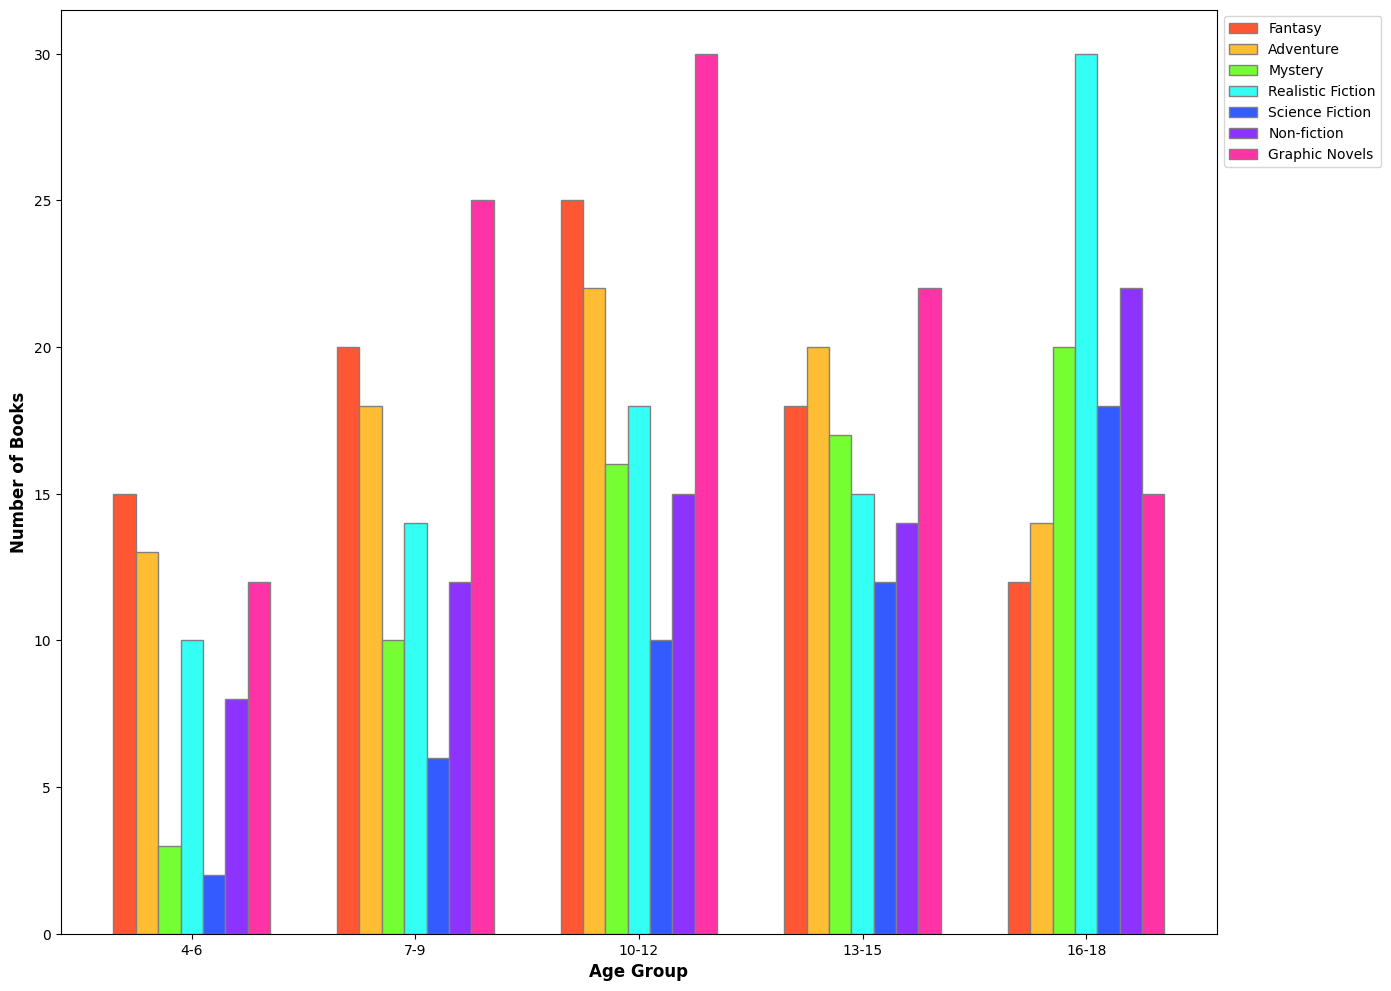Which age group has the highest number of fantasy books? To determine this, we observe the heights of the bars for the "Fantasy" genre across all age groups. The tallest bar for Fantasy belongs to the 10-12 age group.
Answer: 10-12 Which genre has the highest number of books for the 13-15 age group? To find this, we compare the heights of the bars for each genre within the 13-15 age group. The tallest bar is for "Graphic Novels."
Answer: Graphic Novels What is the total number of books for the 16-18 age group across all genres? Sum the numbers for Fantasy, Adventure, Mystery, Realistic Fiction, Science Fiction, Non-fiction, and Graphic Novels for the 16-18 age group: 12 + 14 + 20 + 30 + 18 + 22 + 15 = 131
Answer: 131 Which age group has the fewest adventure books? By comparing the heights of the bars for the "Adventure" genre across all age groups, the shortest bar is for the 4-6 age group.
Answer: 4-6 Are there more realistic fiction books or graphic novels in the 10-12 age group? Compare the heights of the bars for "Realistic Fiction" and "Graphic Novels" in the 10-12 age group. "Graphic Novels" has a taller bar than "Realistic Fiction."
Answer: Graphic Novels Which genre shows a consistent increase in the number of books as the age group increases, if any? By inspecting the bars for each genre across age groups, "Science Fiction" shows an increasing trend from the youngest to the oldest age group.
Answer: Science Fiction How many more mystery books are there in the 10-12 age group compared to the 4-6 age group? Subtract the number for the 4-6 age group from the number for the 10-12 age group for the "Mystery" genre: 16 - 3 = 13
Answer: 13 What is the average number of non-fiction books across all age groups? Sum the numbers for Non-fiction across all age groups and divide by the number of age groups: (8 + 12 + 15 + 14 + 22) / 5 = 14.2
Answer: 14.2 Which age group has the highest diversity in book genres? Diversity can be assessed by the spread of the number of books across different genres. The 10-12 age group has the highest number in multiple genres (e.g., Fantasy, Adventure, Mystery, Graphic Novels) compared to other age groups.
Answer: 10-12 How does the number of realistic fiction books for the 7-9 age group compare to the 13-15 age group? Compare the numbers directly: The 7-9 age group has 14 realistic fiction books, while the 13-15 age group has 15. Thus, the 13-15 age group has 1 more book.
Answer: 1 more book 